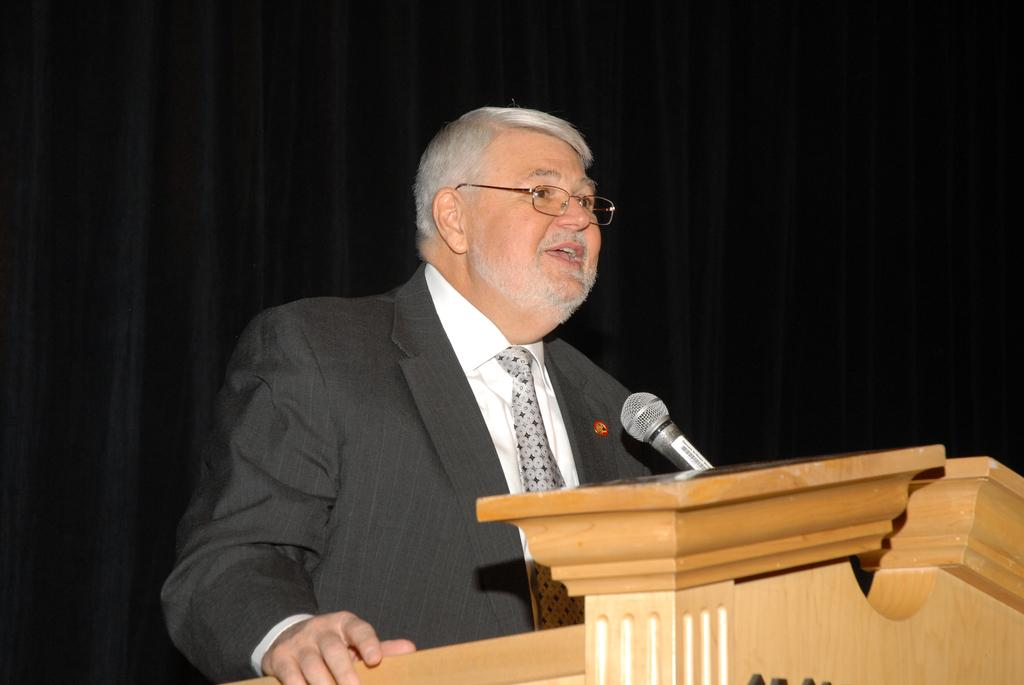Who is the main subject in the image? There is a man in the image. What is the man doing in the image? The man is standing at a podium and speaking. What is the man using to amplify his voice? The man is using a microphone in the image. What type of whip is the man using to control the rat in the image? There is no whip or rat present in the image. 